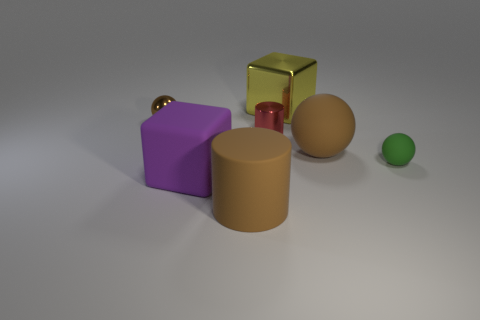Add 2 metallic blocks. How many objects exist? 9 Subtract all blocks. How many objects are left? 5 Add 2 brown matte objects. How many brown matte objects are left? 4 Add 4 brown things. How many brown things exist? 7 Subtract 0 cyan blocks. How many objects are left? 7 Subtract all brown balls. Subtract all big things. How many objects are left? 1 